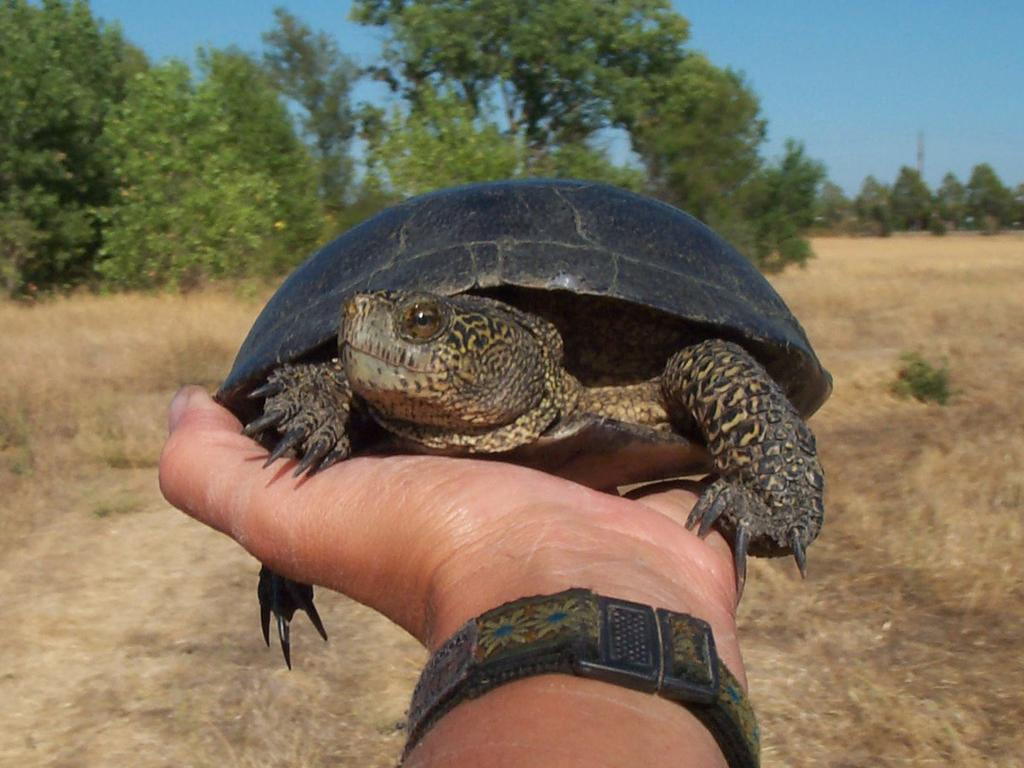What is being held in the foreground of the image? There is a person's hand holding a tortoise in the foreground of the image. What can be seen in the background of the image? There is dry grass and trees in the background of the image. What is visible at the top of the image? The sky is visible at the top of the image. What religious symbols can be seen in the image? There are no religious symbols present in the image. How does the image depict the level of pollution in the area? The image does not depict the level of pollution in the area. The image only shows a person's hand holding a tortoise, dry grass, trees, and the sky. 